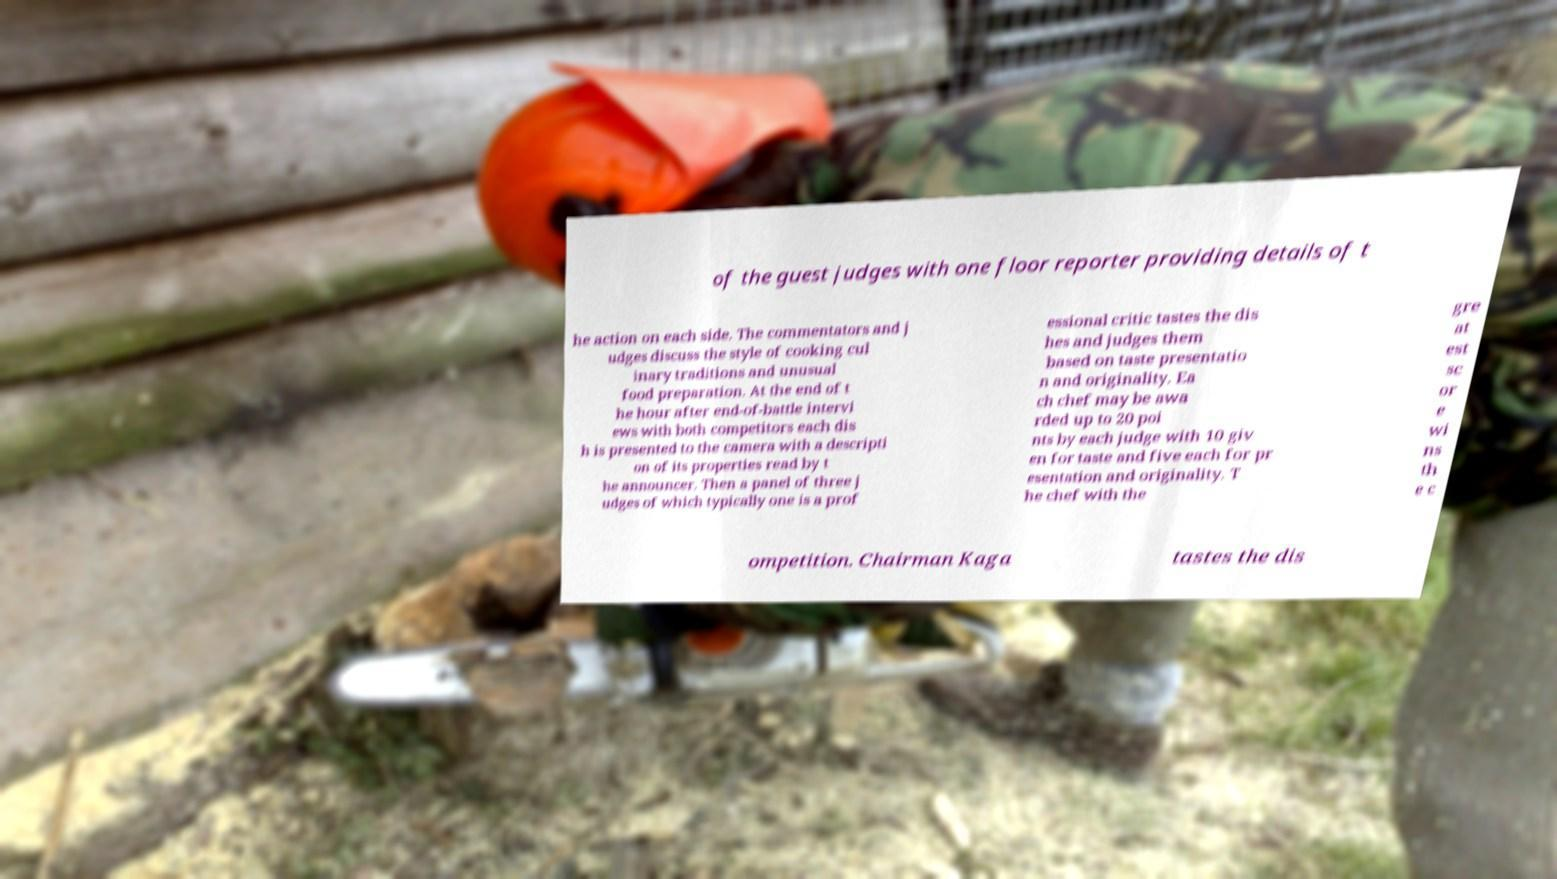I need the written content from this picture converted into text. Can you do that? of the guest judges with one floor reporter providing details of t he action on each side. The commentators and j udges discuss the style of cooking cul inary traditions and unusual food preparation. At the end of t he hour after end-of-battle intervi ews with both competitors each dis h is presented to the camera with a descripti on of its properties read by t he announcer. Then a panel of three j udges of which typically one is a prof essional critic tastes the dis hes and judges them based on taste presentatio n and originality. Ea ch chef may be awa rded up to 20 poi nts by each judge with 10 giv en for taste and five each for pr esentation and originality. T he chef with the gre at est sc or e wi ns th e c ompetition. Chairman Kaga tastes the dis 